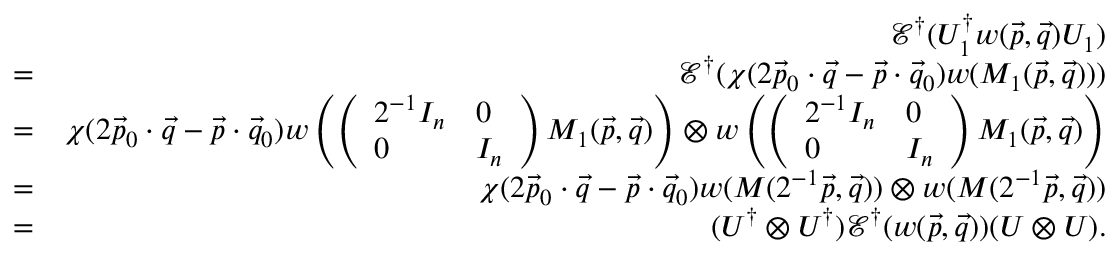Convert formula to latex. <formula><loc_0><loc_0><loc_500><loc_500>\begin{array} { r l r } & { \mathcal { E } ^ { \dag } ( U _ { 1 } ^ { \dag } w ( \vec { p } , \vec { q } ) U _ { 1 } ) } \\ & { = } & { \mathcal { E } ^ { \dag } ( \chi ( 2 \vec { p } _ { 0 } \cdot \vec { q } - \vec { p } \cdot \vec { q } _ { 0 } ) w ( M _ { 1 } ( \vec { p } , \vec { q } ) ) ) } \\ & { = } & { \chi ( 2 \vec { p } _ { 0 } \cdot \vec { q } - \vec { p } \cdot \vec { q } _ { 0 } ) w \left ( \left ( \begin{array} { l l } { 2 ^ { - 1 } I _ { n } } & { 0 } \\ { 0 } & { I _ { n } } \end{array} \right ) M _ { 1 } ( \vec { p } , \vec { q } ) \right ) \otimes w \left ( \left ( \begin{array} { l l } { 2 ^ { - 1 } I _ { n } } & { 0 } \\ { 0 } & { I _ { n } } \end{array} \right ) M _ { 1 } ( \vec { p } , \vec { q } ) \right ) } \\ & { = } & { \chi ( 2 \vec { p } _ { 0 } \cdot \vec { q } - \vec { p } \cdot \vec { q } _ { 0 } ) w ( M ( 2 ^ { - 1 } \vec { p } , \vec { q } ) ) \otimes w ( M ( 2 ^ { - 1 } \vec { p } , \vec { q } ) ) } \\ & { = } & { ( U ^ { \dag } \otimes U ^ { \dag } ) \mathcal { E } ^ { \dag } ( w ( \vec { p } , \vec { q } ) ) ( U \otimes U ) . } \end{array}</formula> 